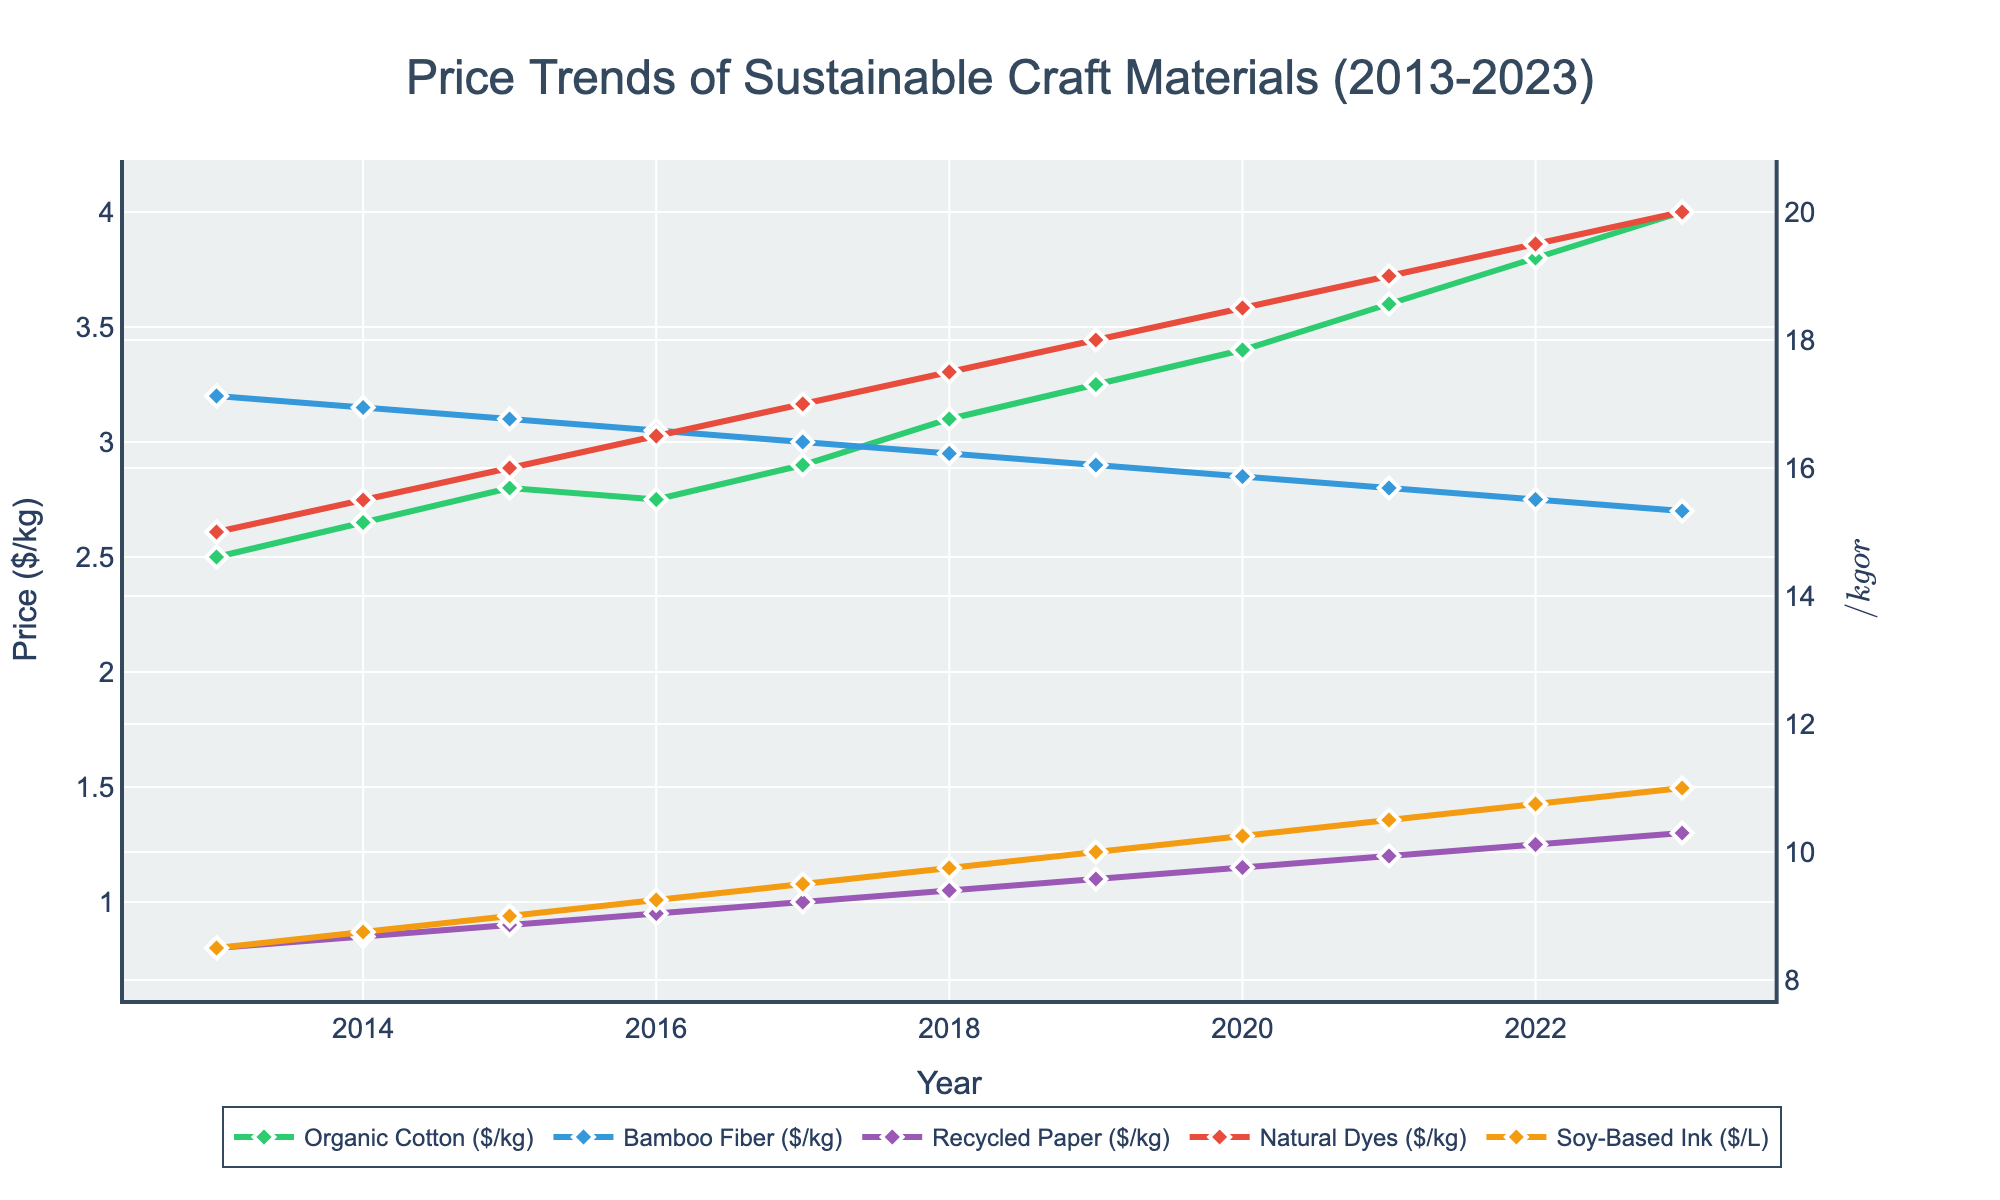what's the trend of the price of Organic Cotton from 2013 to 2023? The figure shows the line representing Organic Cotton's price using a specific color. Starting in 2013, the price steadily increases each year until 2023.
Answer: Increasing which material had the highest price in 2023? The figure includes various materials, each represented by a different colored line. The line for Natural Dyes in 2023 is the highest among all.
Answer: Natural Dyes how did the price of Bamboo Fiber change from 2013 to 2023? The figure shows the trend of Bamboo Fiber using its respective colored line. From 2013 to 2023, the price of Bamboo Fiber consistently decreases each year.
Answer: Decreasing which material showed the most significant price increase from 2013 to 2023? To determine which material had the most significant increase, calculate the difference for each material. Organic Cotton increased from $2.50 to $4.00, which is the largest absolute change.
Answer: Organic Cotton what's the difference between the highest and lowest prices of Soy-Based Ink over the decade? Locate the highest and lowest points of the Soy-Based Ink line. The highest price is $11.00 in 2023, and the lowest price is $8.50 in 2013. The difference is $11.00 - $8.50 = $2.50.
Answer: $2.50 during which year did Recycled Paper and Bamboo Fiber have the smallest difference in price? Observe the two lines for Recycled Paper and Bamboo Fiber. The year when the two lines are closest together is 2023, where the prices are 1.30 and 2.70 respectively.
Answer: 2023 how many materials had price increases every year from 2013 to 2023? Identify the lines that rise every year without any dips. Both Organic Cotton and Recycled Paper show consistently increasing trends.
Answer: 2 compare the variability in prices of Natural Dyes and Bamboo Fiber from 2013 to 2023. Which one is more stable? Check the fluctuations in the lines for Natural Dyes and Bamboo Fiber. Bamboo Fiber shows a steady decline, while Natural Dyes consistently increase. Despite the opposite trends, Bamboo Fiber exhibits less variability.
Answer: Bamboo Fiber calculate the average price of Organic Cotton over the ten years. Sum up the prices of Organic Cotton from 2013 to 2023: 2.50 + 2.65 + 2.80 + 2.75 + 2.90 + 3.10 + 3.25 + 3.40 + 3.60 + 3.80 + 4.00 = 34.75. Divide by 11 years: 34.75 / 11 ≈ 3.16.
Answer: $3.16 which years saw an increase in price for every material? Trace the figure year by year to identify the instances where the prices of all materials increased. Only 2014 has all prices higher than the previous year across every material.
Answer: 2014 